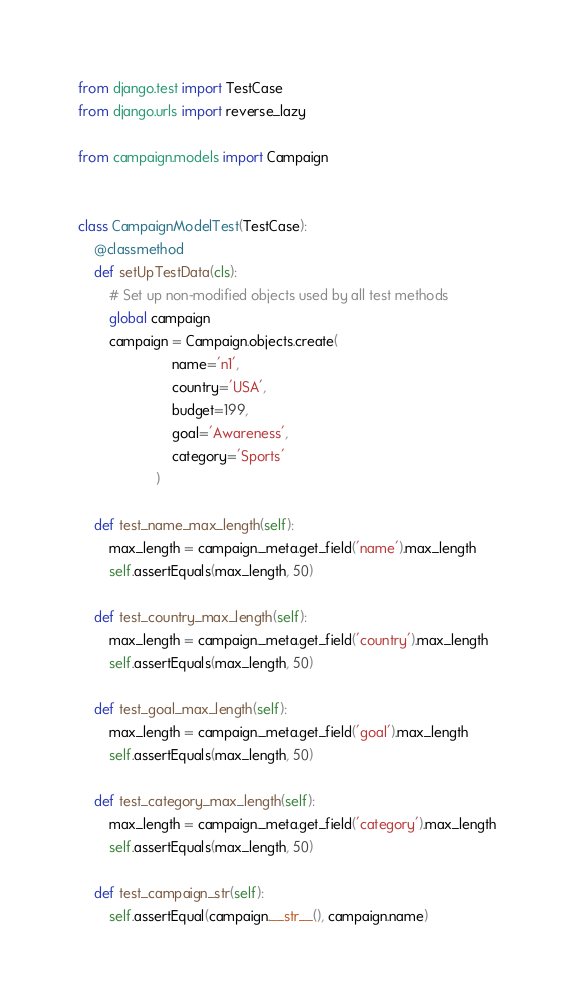<code> <loc_0><loc_0><loc_500><loc_500><_Python_>from django.test import TestCase
from django.urls import reverse_lazy

from campaign.models import Campaign


class CampaignModelTest(TestCase):
    @classmethod
    def setUpTestData(cls):
        # Set up non-modified objects used by all test methods
        global campaign
        campaign = Campaign.objects.create(
                        name='n1',
                        country='USA',
                        budget=199,
                        goal='Awareness',
                        category='Sports'
                    )

    def test_name_max_length(self):
        max_length = campaign._meta.get_field('name').max_length
        self.assertEquals(max_length, 50)

    def test_country_max_length(self):
        max_length = campaign._meta.get_field('country').max_length
        self.assertEquals(max_length, 50)

    def test_goal_max_length(self):
        max_length = campaign._meta.get_field('goal').max_length
        self.assertEquals(max_length, 50)

    def test_category_max_length(self):
        max_length = campaign._meta.get_field('category').max_length
        self.assertEquals(max_length, 50)

    def test_campaign_str(self):
        self.assertEqual(campaign.__str__(), campaign.name)
</code> 